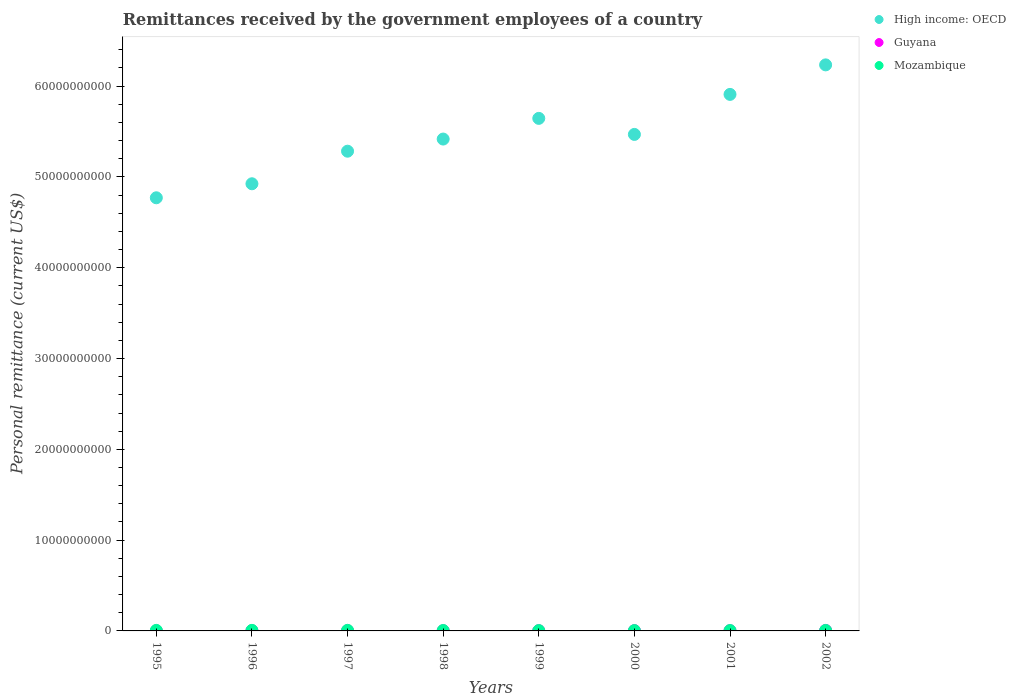How many different coloured dotlines are there?
Give a very brief answer. 3. What is the remittances received by the government employees in Guyana in 1995?
Offer a very short reply. 1.70e+06. Across all years, what is the maximum remittances received by the government employees in Mozambique?
Give a very brief answer. 6.36e+07. Across all years, what is the minimum remittances received by the government employees in Guyana?
Make the answer very short. 1.70e+06. In which year was the remittances received by the government employees in High income: OECD maximum?
Give a very brief answer. 2002. In which year was the remittances received by the government employees in Mozambique minimum?
Offer a very short reply. 2000. What is the total remittances received by the government employees in Guyana in the graph?
Make the answer very short. 1.66e+08. What is the difference between the remittances received by the government employees in High income: OECD in 1996 and that in 1997?
Give a very brief answer. -3.59e+09. What is the difference between the remittances received by the government employees in Guyana in 1998 and the remittances received by the government employees in High income: OECD in 2000?
Keep it short and to the point. -5.47e+1. What is the average remittances received by the government employees in High income: OECD per year?
Offer a terse response. 5.46e+1. In the year 1998, what is the difference between the remittances received by the government employees in Mozambique and remittances received by the government employees in High income: OECD?
Offer a terse response. -5.41e+1. In how many years, is the remittances received by the government employees in High income: OECD greater than 40000000000 US$?
Give a very brief answer. 8. What is the ratio of the remittances received by the government employees in Guyana in 1999 to that in 2002?
Your answer should be compact. 0.4. Is the difference between the remittances received by the government employees in Mozambique in 1998 and 2001 greater than the difference between the remittances received by the government employees in High income: OECD in 1998 and 2001?
Provide a succinct answer. Yes. What is the difference between the highest and the second highest remittances received by the government employees in Mozambique?
Provide a short and direct response. 2.60e+06. What is the difference between the highest and the lowest remittances received by the government employees in Mozambique?
Your response must be concise. 2.68e+07. Is the sum of the remittances received by the government employees in High income: OECD in 1995 and 1997 greater than the maximum remittances received by the government employees in Mozambique across all years?
Make the answer very short. Yes. Does the remittances received by the government employees in High income: OECD monotonically increase over the years?
Keep it short and to the point. No. Is the remittances received by the government employees in High income: OECD strictly less than the remittances received by the government employees in Guyana over the years?
Make the answer very short. No. How many dotlines are there?
Make the answer very short. 3. How many years are there in the graph?
Make the answer very short. 8. What is the difference between two consecutive major ticks on the Y-axis?
Offer a terse response. 1.00e+1. Does the graph contain any zero values?
Your answer should be compact. No. How are the legend labels stacked?
Your response must be concise. Vertical. What is the title of the graph?
Keep it short and to the point. Remittances received by the government employees of a country. What is the label or title of the Y-axis?
Give a very brief answer. Personal remittance (current US$). What is the Personal remittance (current US$) in High income: OECD in 1995?
Keep it short and to the point. 4.77e+1. What is the Personal remittance (current US$) of Guyana in 1995?
Keep it short and to the point. 1.70e+06. What is the Personal remittance (current US$) in Mozambique in 1995?
Ensure brevity in your answer.  5.91e+07. What is the Personal remittance (current US$) in High income: OECD in 1996?
Offer a very short reply. 4.92e+1. What is the Personal remittance (current US$) in Guyana in 1996?
Offer a terse response. 1.46e+07. What is the Personal remittance (current US$) of Mozambique in 1996?
Ensure brevity in your answer.  6.10e+07. What is the Personal remittance (current US$) in High income: OECD in 1997?
Offer a terse response. 5.28e+1. What is the Personal remittance (current US$) in Guyana in 1997?
Give a very brief answer. 1.50e+07. What is the Personal remittance (current US$) in Mozambique in 1997?
Ensure brevity in your answer.  6.36e+07. What is the Personal remittance (current US$) of High income: OECD in 1998?
Provide a short and direct response. 5.42e+1. What is the Personal remittance (current US$) in Guyana in 1998?
Offer a very short reply. 1.40e+07. What is the Personal remittance (current US$) in Mozambique in 1998?
Offer a very short reply. 4.63e+07. What is the Personal remittance (current US$) of High income: OECD in 1999?
Your answer should be compact. 5.64e+1. What is the Personal remittance (current US$) of Guyana in 1999?
Provide a short and direct response. 2.05e+07. What is the Personal remittance (current US$) of Mozambique in 1999?
Ensure brevity in your answer.  3.80e+07. What is the Personal remittance (current US$) of High income: OECD in 2000?
Provide a succinct answer. 5.47e+1. What is the Personal remittance (current US$) of Guyana in 2000?
Keep it short and to the point. 2.73e+07. What is the Personal remittance (current US$) of Mozambique in 2000?
Your answer should be compact. 3.68e+07. What is the Personal remittance (current US$) in High income: OECD in 2001?
Give a very brief answer. 5.91e+1. What is the Personal remittance (current US$) in Guyana in 2001?
Provide a short and direct response. 2.23e+07. What is the Personal remittance (current US$) in Mozambique in 2001?
Offer a terse response. 4.18e+07. What is the Personal remittance (current US$) of High income: OECD in 2002?
Offer a terse response. 6.23e+1. What is the Personal remittance (current US$) in Guyana in 2002?
Offer a terse response. 5.10e+07. What is the Personal remittance (current US$) of Mozambique in 2002?
Offer a very short reply. 5.26e+07. Across all years, what is the maximum Personal remittance (current US$) in High income: OECD?
Your answer should be compact. 6.23e+1. Across all years, what is the maximum Personal remittance (current US$) in Guyana?
Provide a short and direct response. 5.10e+07. Across all years, what is the maximum Personal remittance (current US$) in Mozambique?
Keep it short and to the point. 6.36e+07. Across all years, what is the minimum Personal remittance (current US$) in High income: OECD?
Ensure brevity in your answer.  4.77e+1. Across all years, what is the minimum Personal remittance (current US$) in Guyana?
Your response must be concise. 1.70e+06. Across all years, what is the minimum Personal remittance (current US$) in Mozambique?
Provide a short and direct response. 3.68e+07. What is the total Personal remittance (current US$) of High income: OECD in the graph?
Offer a very short reply. 4.37e+11. What is the total Personal remittance (current US$) of Guyana in the graph?
Make the answer very short. 1.66e+08. What is the total Personal remittance (current US$) of Mozambique in the graph?
Provide a succinct answer. 3.99e+08. What is the difference between the Personal remittance (current US$) of High income: OECD in 1995 and that in 1996?
Offer a terse response. -1.54e+09. What is the difference between the Personal remittance (current US$) of Guyana in 1995 and that in 1996?
Your answer should be very brief. -1.29e+07. What is the difference between the Personal remittance (current US$) in Mozambique in 1995 and that in 1996?
Your answer should be very brief. -1.90e+06. What is the difference between the Personal remittance (current US$) of High income: OECD in 1995 and that in 1997?
Provide a succinct answer. -5.13e+09. What is the difference between the Personal remittance (current US$) in Guyana in 1995 and that in 1997?
Provide a succinct answer. -1.33e+07. What is the difference between the Personal remittance (current US$) of Mozambique in 1995 and that in 1997?
Provide a short and direct response. -4.50e+06. What is the difference between the Personal remittance (current US$) in High income: OECD in 1995 and that in 1998?
Your answer should be very brief. -6.47e+09. What is the difference between the Personal remittance (current US$) of Guyana in 1995 and that in 1998?
Your response must be concise. -1.23e+07. What is the difference between the Personal remittance (current US$) of Mozambique in 1995 and that in 1998?
Keep it short and to the point. 1.28e+07. What is the difference between the Personal remittance (current US$) of High income: OECD in 1995 and that in 1999?
Your response must be concise. -8.75e+09. What is the difference between the Personal remittance (current US$) in Guyana in 1995 and that in 1999?
Provide a succinct answer. -1.88e+07. What is the difference between the Personal remittance (current US$) of Mozambique in 1995 and that in 1999?
Your response must be concise. 2.11e+07. What is the difference between the Personal remittance (current US$) in High income: OECD in 1995 and that in 2000?
Give a very brief answer. -6.98e+09. What is the difference between the Personal remittance (current US$) in Guyana in 1995 and that in 2000?
Offer a very short reply. -2.56e+07. What is the difference between the Personal remittance (current US$) in Mozambique in 1995 and that in 2000?
Your response must be concise. 2.23e+07. What is the difference between the Personal remittance (current US$) of High income: OECD in 1995 and that in 2001?
Offer a very short reply. -1.14e+1. What is the difference between the Personal remittance (current US$) in Guyana in 1995 and that in 2001?
Offer a very short reply. -2.06e+07. What is the difference between the Personal remittance (current US$) in Mozambique in 1995 and that in 2001?
Keep it short and to the point. 1.73e+07. What is the difference between the Personal remittance (current US$) in High income: OECD in 1995 and that in 2002?
Offer a very short reply. -1.46e+1. What is the difference between the Personal remittance (current US$) in Guyana in 1995 and that in 2002?
Your answer should be compact. -4.93e+07. What is the difference between the Personal remittance (current US$) in Mozambique in 1995 and that in 2002?
Your response must be concise. 6.55e+06. What is the difference between the Personal remittance (current US$) of High income: OECD in 1996 and that in 1997?
Give a very brief answer. -3.59e+09. What is the difference between the Personal remittance (current US$) in Guyana in 1996 and that in 1997?
Ensure brevity in your answer.  -4.00e+05. What is the difference between the Personal remittance (current US$) of Mozambique in 1996 and that in 1997?
Provide a short and direct response. -2.60e+06. What is the difference between the Personal remittance (current US$) in High income: OECD in 1996 and that in 1998?
Your answer should be compact. -4.92e+09. What is the difference between the Personal remittance (current US$) in Guyana in 1996 and that in 1998?
Ensure brevity in your answer.  6.00e+05. What is the difference between the Personal remittance (current US$) of Mozambique in 1996 and that in 1998?
Offer a terse response. 1.47e+07. What is the difference between the Personal remittance (current US$) in High income: OECD in 1996 and that in 1999?
Offer a very short reply. -7.20e+09. What is the difference between the Personal remittance (current US$) of Guyana in 1996 and that in 1999?
Your answer should be compact. -5.90e+06. What is the difference between the Personal remittance (current US$) in Mozambique in 1996 and that in 1999?
Ensure brevity in your answer.  2.30e+07. What is the difference between the Personal remittance (current US$) in High income: OECD in 1996 and that in 2000?
Make the answer very short. -5.44e+09. What is the difference between the Personal remittance (current US$) in Guyana in 1996 and that in 2000?
Offer a very short reply. -1.27e+07. What is the difference between the Personal remittance (current US$) in Mozambique in 1996 and that in 2000?
Your response must be concise. 2.42e+07. What is the difference between the Personal remittance (current US$) of High income: OECD in 1996 and that in 2001?
Offer a terse response. -9.84e+09. What is the difference between the Personal remittance (current US$) of Guyana in 1996 and that in 2001?
Ensure brevity in your answer.  -7.70e+06. What is the difference between the Personal remittance (current US$) in Mozambique in 1996 and that in 2001?
Offer a terse response. 1.92e+07. What is the difference between the Personal remittance (current US$) of High income: OECD in 1996 and that in 2002?
Make the answer very short. -1.31e+1. What is the difference between the Personal remittance (current US$) in Guyana in 1996 and that in 2002?
Make the answer very short. -3.64e+07. What is the difference between the Personal remittance (current US$) of Mozambique in 1996 and that in 2002?
Keep it short and to the point. 8.45e+06. What is the difference between the Personal remittance (current US$) in High income: OECD in 1997 and that in 1998?
Your response must be concise. -1.34e+09. What is the difference between the Personal remittance (current US$) in Guyana in 1997 and that in 1998?
Keep it short and to the point. 1.00e+06. What is the difference between the Personal remittance (current US$) in Mozambique in 1997 and that in 1998?
Your answer should be very brief. 1.73e+07. What is the difference between the Personal remittance (current US$) of High income: OECD in 1997 and that in 1999?
Offer a terse response. -3.61e+09. What is the difference between the Personal remittance (current US$) in Guyana in 1997 and that in 1999?
Provide a short and direct response. -5.50e+06. What is the difference between the Personal remittance (current US$) in Mozambique in 1997 and that in 1999?
Your answer should be very brief. 2.56e+07. What is the difference between the Personal remittance (current US$) of High income: OECD in 1997 and that in 2000?
Provide a succinct answer. -1.85e+09. What is the difference between the Personal remittance (current US$) of Guyana in 1997 and that in 2000?
Your response must be concise. -1.23e+07. What is the difference between the Personal remittance (current US$) of Mozambique in 1997 and that in 2000?
Your response must be concise. 2.68e+07. What is the difference between the Personal remittance (current US$) of High income: OECD in 1997 and that in 2001?
Offer a very short reply. -6.26e+09. What is the difference between the Personal remittance (current US$) in Guyana in 1997 and that in 2001?
Keep it short and to the point. -7.30e+06. What is the difference between the Personal remittance (current US$) of Mozambique in 1997 and that in 2001?
Your response must be concise. 2.18e+07. What is the difference between the Personal remittance (current US$) in High income: OECD in 1997 and that in 2002?
Your response must be concise. -9.51e+09. What is the difference between the Personal remittance (current US$) in Guyana in 1997 and that in 2002?
Keep it short and to the point. -3.60e+07. What is the difference between the Personal remittance (current US$) in Mozambique in 1997 and that in 2002?
Your response must be concise. 1.10e+07. What is the difference between the Personal remittance (current US$) of High income: OECD in 1998 and that in 1999?
Provide a short and direct response. -2.28e+09. What is the difference between the Personal remittance (current US$) in Guyana in 1998 and that in 1999?
Your answer should be compact. -6.50e+06. What is the difference between the Personal remittance (current US$) of Mozambique in 1998 and that in 1999?
Your answer should be compact. 8.30e+06. What is the difference between the Personal remittance (current US$) of High income: OECD in 1998 and that in 2000?
Ensure brevity in your answer.  -5.11e+08. What is the difference between the Personal remittance (current US$) of Guyana in 1998 and that in 2000?
Give a very brief answer. -1.33e+07. What is the difference between the Personal remittance (current US$) of Mozambique in 1998 and that in 2000?
Your answer should be compact. 9.50e+06. What is the difference between the Personal remittance (current US$) in High income: OECD in 1998 and that in 2001?
Your response must be concise. -4.92e+09. What is the difference between the Personal remittance (current US$) of Guyana in 1998 and that in 2001?
Your answer should be compact. -8.30e+06. What is the difference between the Personal remittance (current US$) of Mozambique in 1998 and that in 2001?
Give a very brief answer. 4.48e+06. What is the difference between the Personal remittance (current US$) of High income: OECD in 1998 and that in 2002?
Give a very brief answer. -8.17e+09. What is the difference between the Personal remittance (current US$) in Guyana in 1998 and that in 2002?
Offer a very short reply. -3.70e+07. What is the difference between the Personal remittance (current US$) in Mozambique in 1998 and that in 2002?
Make the answer very short. -6.25e+06. What is the difference between the Personal remittance (current US$) in High income: OECD in 1999 and that in 2000?
Make the answer very short. 1.77e+09. What is the difference between the Personal remittance (current US$) of Guyana in 1999 and that in 2000?
Provide a short and direct response. -6.80e+06. What is the difference between the Personal remittance (current US$) in Mozambique in 1999 and that in 2000?
Your response must be concise. 1.20e+06. What is the difference between the Personal remittance (current US$) of High income: OECD in 1999 and that in 2001?
Your response must be concise. -2.64e+09. What is the difference between the Personal remittance (current US$) in Guyana in 1999 and that in 2001?
Make the answer very short. -1.80e+06. What is the difference between the Personal remittance (current US$) of Mozambique in 1999 and that in 2001?
Keep it short and to the point. -3.82e+06. What is the difference between the Personal remittance (current US$) of High income: OECD in 1999 and that in 2002?
Give a very brief answer. -5.89e+09. What is the difference between the Personal remittance (current US$) in Guyana in 1999 and that in 2002?
Your answer should be very brief. -3.05e+07. What is the difference between the Personal remittance (current US$) of Mozambique in 1999 and that in 2002?
Give a very brief answer. -1.46e+07. What is the difference between the Personal remittance (current US$) in High income: OECD in 2000 and that in 2001?
Give a very brief answer. -4.41e+09. What is the difference between the Personal remittance (current US$) in Mozambique in 2000 and that in 2001?
Ensure brevity in your answer.  -5.02e+06. What is the difference between the Personal remittance (current US$) in High income: OECD in 2000 and that in 2002?
Your answer should be very brief. -7.66e+09. What is the difference between the Personal remittance (current US$) of Guyana in 2000 and that in 2002?
Make the answer very short. -2.37e+07. What is the difference between the Personal remittance (current US$) of Mozambique in 2000 and that in 2002?
Your answer should be compact. -1.58e+07. What is the difference between the Personal remittance (current US$) in High income: OECD in 2001 and that in 2002?
Offer a terse response. -3.25e+09. What is the difference between the Personal remittance (current US$) in Guyana in 2001 and that in 2002?
Your response must be concise. -2.87e+07. What is the difference between the Personal remittance (current US$) in Mozambique in 2001 and that in 2002?
Make the answer very short. -1.07e+07. What is the difference between the Personal remittance (current US$) in High income: OECD in 1995 and the Personal remittance (current US$) in Guyana in 1996?
Your response must be concise. 4.77e+1. What is the difference between the Personal remittance (current US$) of High income: OECD in 1995 and the Personal remittance (current US$) of Mozambique in 1996?
Your response must be concise. 4.76e+1. What is the difference between the Personal remittance (current US$) of Guyana in 1995 and the Personal remittance (current US$) of Mozambique in 1996?
Your answer should be compact. -5.93e+07. What is the difference between the Personal remittance (current US$) in High income: OECD in 1995 and the Personal remittance (current US$) in Guyana in 1997?
Your answer should be very brief. 4.77e+1. What is the difference between the Personal remittance (current US$) of High income: OECD in 1995 and the Personal remittance (current US$) of Mozambique in 1997?
Your response must be concise. 4.76e+1. What is the difference between the Personal remittance (current US$) in Guyana in 1995 and the Personal remittance (current US$) in Mozambique in 1997?
Provide a short and direct response. -6.19e+07. What is the difference between the Personal remittance (current US$) in High income: OECD in 1995 and the Personal remittance (current US$) in Guyana in 1998?
Your response must be concise. 4.77e+1. What is the difference between the Personal remittance (current US$) in High income: OECD in 1995 and the Personal remittance (current US$) in Mozambique in 1998?
Your answer should be compact. 4.77e+1. What is the difference between the Personal remittance (current US$) in Guyana in 1995 and the Personal remittance (current US$) in Mozambique in 1998?
Ensure brevity in your answer.  -4.46e+07. What is the difference between the Personal remittance (current US$) of High income: OECD in 1995 and the Personal remittance (current US$) of Guyana in 1999?
Offer a terse response. 4.77e+1. What is the difference between the Personal remittance (current US$) of High income: OECD in 1995 and the Personal remittance (current US$) of Mozambique in 1999?
Ensure brevity in your answer.  4.77e+1. What is the difference between the Personal remittance (current US$) of Guyana in 1995 and the Personal remittance (current US$) of Mozambique in 1999?
Your answer should be compact. -3.63e+07. What is the difference between the Personal remittance (current US$) in High income: OECD in 1995 and the Personal remittance (current US$) in Guyana in 2000?
Your answer should be compact. 4.77e+1. What is the difference between the Personal remittance (current US$) of High income: OECD in 1995 and the Personal remittance (current US$) of Mozambique in 2000?
Keep it short and to the point. 4.77e+1. What is the difference between the Personal remittance (current US$) in Guyana in 1995 and the Personal remittance (current US$) in Mozambique in 2000?
Your response must be concise. -3.51e+07. What is the difference between the Personal remittance (current US$) in High income: OECD in 1995 and the Personal remittance (current US$) in Guyana in 2001?
Your answer should be very brief. 4.77e+1. What is the difference between the Personal remittance (current US$) of High income: OECD in 1995 and the Personal remittance (current US$) of Mozambique in 2001?
Keep it short and to the point. 4.77e+1. What is the difference between the Personal remittance (current US$) of Guyana in 1995 and the Personal remittance (current US$) of Mozambique in 2001?
Provide a succinct answer. -4.01e+07. What is the difference between the Personal remittance (current US$) in High income: OECD in 1995 and the Personal remittance (current US$) in Guyana in 2002?
Offer a terse response. 4.77e+1. What is the difference between the Personal remittance (current US$) of High income: OECD in 1995 and the Personal remittance (current US$) of Mozambique in 2002?
Keep it short and to the point. 4.77e+1. What is the difference between the Personal remittance (current US$) of Guyana in 1995 and the Personal remittance (current US$) of Mozambique in 2002?
Your answer should be very brief. -5.09e+07. What is the difference between the Personal remittance (current US$) in High income: OECD in 1996 and the Personal remittance (current US$) in Guyana in 1997?
Ensure brevity in your answer.  4.92e+1. What is the difference between the Personal remittance (current US$) of High income: OECD in 1996 and the Personal remittance (current US$) of Mozambique in 1997?
Make the answer very short. 4.92e+1. What is the difference between the Personal remittance (current US$) of Guyana in 1996 and the Personal remittance (current US$) of Mozambique in 1997?
Offer a terse response. -4.90e+07. What is the difference between the Personal remittance (current US$) in High income: OECD in 1996 and the Personal remittance (current US$) in Guyana in 1998?
Give a very brief answer. 4.92e+1. What is the difference between the Personal remittance (current US$) of High income: OECD in 1996 and the Personal remittance (current US$) of Mozambique in 1998?
Provide a short and direct response. 4.92e+1. What is the difference between the Personal remittance (current US$) of Guyana in 1996 and the Personal remittance (current US$) of Mozambique in 1998?
Offer a terse response. -3.17e+07. What is the difference between the Personal remittance (current US$) of High income: OECD in 1996 and the Personal remittance (current US$) of Guyana in 1999?
Provide a short and direct response. 4.92e+1. What is the difference between the Personal remittance (current US$) of High income: OECD in 1996 and the Personal remittance (current US$) of Mozambique in 1999?
Give a very brief answer. 4.92e+1. What is the difference between the Personal remittance (current US$) in Guyana in 1996 and the Personal remittance (current US$) in Mozambique in 1999?
Offer a very short reply. -2.34e+07. What is the difference between the Personal remittance (current US$) in High income: OECD in 1996 and the Personal remittance (current US$) in Guyana in 2000?
Provide a succinct answer. 4.92e+1. What is the difference between the Personal remittance (current US$) in High income: OECD in 1996 and the Personal remittance (current US$) in Mozambique in 2000?
Provide a succinct answer. 4.92e+1. What is the difference between the Personal remittance (current US$) in Guyana in 1996 and the Personal remittance (current US$) in Mozambique in 2000?
Offer a terse response. -2.22e+07. What is the difference between the Personal remittance (current US$) in High income: OECD in 1996 and the Personal remittance (current US$) in Guyana in 2001?
Your response must be concise. 4.92e+1. What is the difference between the Personal remittance (current US$) of High income: OECD in 1996 and the Personal remittance (current US$) of Mozambique in 2001?
Your answer should be very brief. 4.92e+1. What is the difference between the Personal remittance (current US$) of Guyana in 1996 and the Personal remittance (current US$) of Mozambique in 2001?
Make the answer very short. -2.72e+07. What is the difference between the Personal remittance (current US$) of High income: OECD in 1996 and the Personal remittance (current US$) of Guyana in 2002?
Offer a very short reply. 4.92e+1. What is the difference between the Personal remittance (current US$) of High income: OECD in 1996 and the Personal remittance (current US$) of Mozambique in 2002?
Make the answer very short. 4.92e+1. What is the difference between the Personal remittance (current US$) in Guyana in 1996 and the Personal remittance (current US$) in Mozambique in 2002?
Your response must be concise. -3.80e+07. What is the difference between the Personal remittance (current US$) of High income: OECD in 1997 and the Personal remittance (current US$) of Guyana in 1998?
Make the answer very short. 5.28e+1. What is the difference between the Personal remittance (current US$) of High income: OECD in 1997 and the Personal remittance (current US$) of Mozambique in 1998?
Your answer should be compact. 5.28e+1. What is the difference between the Personal remittance (current US$) in Guyana in 1997 and the Personal remittance (current US$) in Mozambique in 1998?
Offer a very short reply. -3.13e+07. What is the difference between the Personal remittance (current US$) of High income: OECD in 1997 and the Personal remittance (current US$) of Guyana in 1999?
Keep it short and to the point. 5.28e+1. What is the difference between the Personal remittance (current US$) of High income: OECD in 1997 and the Personal remittance (current US$) of Mozambique in 1999?
Your response must be concise. 5.28e+1. What is the difference between the Personal remittance (current US$) in Guyana in 1997 and the Personal remittance (current US$) in Mozambique in 1999?
Your answer should be very brief. -2.30e+07. What is the difference between the Personal remittance (current US$) in High income: OECD in 1997 and the Personal remittance (current US$) in Guyana in 2000?
Keep it short and to the point. 5.28e+1. What is the difference between the Personal remittance (current US$) of High income: OECD in 1997 and the Personal remittance (current US$) of Mozambique in 2000?
Offer a terse response. 5.28e+1. What is the difference between the Personal remittance (current US$) in Guyana in 1997 and the Personal remittance (current US$) in Mozambique in 2000?
Keep it short and to the point. -2.18e+07. What is the difference between the Personal remittance (current US$) in High income: OECD in 1997 and the Personal remittance (current US$) in Guyana in 2001?
Offer a very short reply. 5.28e+1. What is the difference between the Personal remittance (current US$) in High income: OECD in 1997 and the Personal remittance (current US$) in Mozambique in 2001?
Provide a short and direct response. 5.28e+1. What is the difference between the Personal remittance (current US$) of Guyana in 1997 and the Personal remittance (current US$) of Mozambique in 2001?
Provide a succinct answer. -2.68e+07. What is the difference between the Personal remittance (current US$) in High income: OECD in 1997 and the Personal remittance (current US$) in Guyana in 2002?
Ensure brevity in your answer.  5.28e+1. What is the difference between the Personal remittance (current US$) of High income: OECD in 1997 and the Personal remittance (current US$) of Mozambique in 2002?
Your answer should be compact. 5.28e+1. What is the difference between the Personal remittance (current US$) in Guyana in 1997 and the Personal remittance (current US$) in Mozambique in 2002?
Offer a terse response. -3.76e+07. What is the difference between the Personal remittance (current US$) of High income: OECD in 1998 and the Personal remittance (current US$) of Guyana in 1999?
Ensure brevity in your answer.  5.42e+1. What is the difference between the Personal remittance (current US$) in High income: OECD in 1998 and the Personal remittance (current US$) in Mozambique in 1999?
Make the answer very short. 5.41e+1. What is the difference between the Personal remittance (current US$) in Guyana in 1998 and the Personal remittance (current US$) in Mozambique in 1999?
Provide a succinct answer. -2.40e+07. What is the difference between the Personal remittance (current US$) of High income: OECD in 1998 and the Personal remittance (current US$) of Guyana in 2000?
Offer a very short reply. 5.41e+1. What is the difference between the Personal remittance (current US$) of High income: OECD in 1998 and the Personal remittance (current US$) of Mozambique in 2000?
Your response must be concise. 5.41e+1. What is the difference between the Personal remittance (current US$) in Guyana in 1998 and the Personal remittance (current US$) in Mozambique in 2000?
Make the answer very short. -2.28e+07. What is the difference between the Personal remittance (current US$) in High income: OECD in 1998 and the Personal remittance (current US$) in Guyana in 2001?
Your answer should be compact. 5.41e+1. What is the difference between the Personal remittance (current US$) of High income: OECD in 1998 and the Personal remittance (current US$) of Mozambique in 2001?
Offer a terse response. 5.41e+1. What is the difference between the Personal remittance (current US$) in Guyana in 1998 and the Personal remittance (current US$) in Mozambique in 2001?
Make the answer very short. -2.78e+07. What is the difference between the Personal remittance (current US$) of High income: OECD in 1998 and the Personal remittance (current US$) of Guyana in 2002?
Your answer should be very brief. 5.41e+1. What is the difference between the Personal remittance (current US$) in High income: OECD in 1998 and the Personal remittance (current US$) in Mozambique in 2002?
Offer a very short reply. 5.41e+1. What is the difference between the Personal remittance (current US$) in Guyana in 1998 and the Personal remittance (current US$) in Mozambique in 2002?
Make the answer very short. -3.86e+07. What is the difference between the Personal remittance (current US$) of High income: OECD in 1999 and the Personal remittance (current US$) of Guyana in 2000?
Offer a very short reply. 5.64e+1. What is the difference between the Personal remittance (current US$) of High income: OECD in 1999 and the Personal remittance (current US$) of Mozambique in 2000?
Make the answer very short. 5.64e+1. What is the difference between the Personal remittance (current US$) in Guyana in 1999 and the Personal remittance (current US$) in Mozambique in 2000?
Offer a very short reply. -1.63e+07. What is the difference between the Personal remittance (current US$) in High income: OECD in 1999 and the Personal remittance (current US$) in Guyana in 2001?
Provide a short and direct response. 5.64e+1. What is the difference between the Personal remittance (current US$) of High income: OECD in 1999 and the Personal remittance (current US$) of Mozambique in 2001?
Offer a terse response. 5.64e+1. What is the difference between the Personal remittance (current US$) of Guyana in 1999 and the Personal remittance (current US$) of Mozambique in 2001?
Your response must be concise. -2.13e+07. What is the difference between the Personal remittance (current US$) of High income: OECD in 1999 and the Personal remittance (current US$) of Guyana in 2002?
Make the answer very short. 5.64e+1. What is the difference between the Personal remittance (current US$) of High income: OECD in 1999 and the Personal remittance (current US$) of Mozambique in 2002?
Ensure brevity in your answer.  5.64e+1. What is the difference between the Personal remittance (current US$) of Guyana in 1999 and the Personal remittance (current US$) of Mozambique in 2002?
Ensure brevity in your answer.  -3.21e+07. What is the difference between the Personal remittance (current US$) in High income: OECD in 2000 and the Personal remittance (current US$) in Guyana in 2001?
Your answer should be very brief. 5.47e+1. What is the difference between the Personal remittance (current US$) in High income: OECD in 2000 and the Personal remittance (current US$) in Mozambique in 2001?
Make the answer very short. 5.46e+1. What is the difference between the Personal remittance (current US$) in Guyana in 2000 and the Personal remittance (current US$) in Mozambique in 2001?
Your response must be concise. -1.45e+07. What is the difference between the Personal remittance (current US$) in High income: OECD in 2000 and the Personal remittance (current US$) in Guyana in 2002?
Offer a very short reply. 5.46e+1. What is the difference between the Personal remittance (current US$) of High income: OECD in 2000 and the Personal remittance (current US$) of Mozambique in 2002?
Make the answer very short. 5.46e+1. What is the difference between the Personal remittance (current US$) in Guyana in 2000 and the Personal remittance (current US$) in Mozambique in 2002?
Offer a very short reply. -2.53e+07. What is the difference between the Personal remittance (current US$) in High income: OECD in 2001 and the Personal remittance (current US$) in Guyana in 2002?
Your answer should be very brief. 5.90e+1. What is the difference between the Personal remittance (current US$) of High income: OECD in 2001 and the Personal remittance (current US$) of Mozambique in 2002?
Give a very brief answer. 5.90e+1. What is the difference between the Personal remittance (current US$) in Guyana in 2001 and the Personal remittance (current US$) in Mozambique in 2002?
Provide a short and direct response. -3.03e+07. What is the average Personal remittance (current US$) of High income: OECD per year?
Provide a short and direct response. 5.46e+1. What is the average Personal remittance (current US$) of Guyana per year?
Your answer should be very brief. 2.08e+07. What is the average Personal remittance (current US$) of Mozambique per year?
Provide a succinct answer. 4.99e+07. In the year 1995, what is the difference between the Personal remittance (current US$) of High income: OECD and Personal remittance (current US$) of Guyana?
Offer a terse response. 4.77e+1. In the year 1995, what is the difference between the Personal remittance (current US$) of High income: OECD and Personal remittance (current US$) of Mozambique?
Ensure brevity in your answer.  4.76e+1. In the year 1995, what is the difference between the Personal remittance (current US$) of Guyana and Personal remittance (current US$) of Mozambique?
Your response must be concise. -5.74e+07. In the year 1996, what is the difference between the Personal remittance (current US$) in High income: OECD and Personal remittance (current US$) in Guyana?
Offer a very short reply. 4.92e+1. In the year 1996, what is the difference between the Personal remittance (current US$) in High income: OECD and Personal remittance (current US$) in Mozambique?
Your response must be concise. 4.92e+1. In the year 1996, what is the difference between the Personal remittance (current US$) in Guyana and Personal remittance (current US$) in Mozambique?
Give a very brief answer. -4.64e+07. In the year 1997, what is the difference between the Personal remittance (current US$) in High income: OECD and Personal remittance (current US$) in Guyana?
Give a very brief answer. 5.28e+1. In the year 1997, what is the difference between the Personal remittance (current US$) in High income: OECD and Personal remittance (current US$) in Mozambique?
Keep it short and to the point. 5.28e+1. In the year 1997, what is the difference between the Personal remittance (current US$) of Guyana and Personal remittance (current US$) of Mozambique?
Keep it short and to the point. -4.86e+07. In the year 1998, what is the difference between the Personal remittance (current US$) in High income: OECD and Personal remittance (current US$) in Guyana?
Give a very brief answer. 5.42e+1. In the year 1998, what is the difference between the Personal remittance (current US$) in High income: OECD and Personal remittance (current US$) in Mozambique?
Your answer should be very brief. 5.41e+1. In the year 1998, what is the difference between the Personal remittance (current US$) of Guyana and Personal remittance (current US$) of Mozambique?
Your answer should be compact. -3.23e+07. In the year 1999, what is the difference between the Personal remittance (current US$) of High income: OECD and Personal remittance (current US$) of Guyana?
Your answer should be very brief. 5.64e+1. In the year 1999, what is the difference between the Personal remittance (current US$) of High income: OECD and Personal remittance (current US$) of Mozambique?
Provide a short and direct response. 5.64e+1. In the year 1999, what is the difference between the Personal remittance (current US$) of Guyana and Personal remittance (current US$) of Mozambique?
Your answer should be compact. -1.75e+07. In the year 2000, what is the difference between the Personal remittance (current US$) of High income: OECD and Personal remittance (current US$) of Guyana?
Your answer should be very brief. 5.47e+1. In the year 2000, what is the difference between the Personal remittance (current US$) of High income: OECD and Personal remittance (current US$) of Mozambique?
Your answer should be very brief. 5.46e+1. In the year 2000, what is the difference between the Personal remittance (current US$) in Guyana and Personal remittance (current US$) in Mozambique?
Offer a very short reply. -9.50e+06. In the year 2001, what is the difference between the Personal remittance (current US$) of High income: OECD and Personal remittance (current US$) of Guyana?
Provide a succinct answer. 5.91e+1. In the year 2001, what is the difference between the Personal remittance (current US$) of High income: OECD and Personal remittance (current US$) of Mozambique?
Provide a succinct answer. 5.90e+1. In the year 2001, what is the difference between the Personal remittance (current US$) of Guyana and Personal remittance (current US$) of Mozambique?
Your answer should be very brief. -1.95e+07. In the year 2002, what is the difference between the Personal remittance (current US$) of High income: OECD and Personal remittance (current US$) of Guyana?
Your answer should be compact. 6.23e+1. In the year 2002, what is the difference between the Personal remittance (current US$) of High income: OECD and Personal remittance (current US$) of Mozambique?
Provide a succinct answer. 6.23e+1. In the year 2002, what is the difference between the Personal remittance (current US$) in Guyana and Personal remittance (current US$) in Mozambique?
Make the answer very short. -1.55e+06. What is the ratio of the Personal remittance (current US$) in High income: OECD in 1995 to that in 1996?
Your answer should be compact. 0.97. What is the ratio of the Personal remittance (current US$) of Guyana in 1995 to that in 1996?
Provide a short and direct response. 0.12. What is the ratio of the Personal remittance (current US$) in Mozambique in 1995 to that in 1996?
Ensure brevity in your answer.  0.97. What is the ratio of the Personal remittance (current US$) of High income: OECD in 1995 to that in 1997?
Your answer should be compact. 0.9. What is the ratio of the Personal remittance (current US$) in Guyana in 1995 to that in 1997?
Ensure brevity in your answer.  0.11. What is the ratio of the Personal remittance (current US$) in Mozambique in 1995 to that in 1997?
Make the answer very short. 0.93. What is the ratio of the Personal remittance (current US$) of High income: OECD in 1995 to that in 1998?
Keep it short and to the point. 0.88. What is the ratio of the Personal remittance (current US$) of Guyana in 1995 to that in 1998?
Your answer should be compact. 0.12. What is the ratio of the Personal remittance (current US$) in Mozambique in 1995 to that in 1998?
Provide a succinct answer. 1.28. What is the ratio of the Personal remittance (current US$) in High income: OECD in 1995 to that in 1999?
Make the answer very short. 0.85. What is the ratio of the Personal remittance (current US$) in Guyana in 1995 to that in 1999?
Ensure brevity in your answer.  0.08. What is the ratio of the Personal remittance (current US$) in Mozambique in 1995 to that in 1999?
Make the answer very short. 1.56. What is the ratio of the Personal remittance (current US$) in High income: OECD in 1995 to that in 2000?
Offer a very short reply. 0.87. What is the ratio of the Personal remittance (current US$) in Guyana in 1995 to that in 2000?
Keep it short and to the point. 0.06. What is the ratio of the Personal remittance (current US$) of Mozambique in 1995 to that in 2000?
Provide a succinct answer. 1.61. What is the ratio of the Personal remittance (current US$) of High income: OECD in 1995 to that in 2001?
Offer a terse response. 0.81. What is the ratio of the Personal remittance (current US$) in Guyana in 1995 to that in 2001?
Give a very brief answer. 0.08. What is the ratio of the Personal remittance (current US$) in Mozambique in 1995 to that in 2001?
Your answer should be compact. 1.41. What is the ratio of the Personal remittance (current US$) of High income: OECD in 1995 to that in 2002?
Make the answer very short. 0.77. What is the ratio of the Personal remittance (current US$) of Guyana in 1995 to that in 2002?
Provide a succinct answer. 0.03. What is the ratio of the Personal remittance (current US$) in Mozambique in 1995 to that in 2002?
Provide a succinct answer. 1.12. What is the ratio of the Personal remittance (current US$) of High income: OECD in 1996 to that in 1997?
Your answer should be compact. 0.93. What is the ratio of the Personal remittance (current US$) in Guyana in 1996 to that in 1997?
Provide a succinct answer. 0.97. What is the ratio of the Personal remittance (current US$) in Mozambique in 1996 to that in 1997?
Provide a succinct answer. 0.96. What is the ratio of the Personal remittance (current US$) of High income: OECD in 1996 to that in 1998?
Make the answer very short. 0.91. What is the ratio of the Personal remittance (current US$) in Guyana in 1996 to that in 1998?
Ensure brevity in your answer.  1.04. What is the ratio of the Personal remittance (current US$) of Mozambique in 1996 to that in 1998?
Give a very brief answer. 1.32. What is the ratio of the Personal remittance (current US$) of High income: OECD in 1996 to that in 1999?
Provide a succinct answer. 0.87. What is the ratio of the Personal remittance (current US$) of Guyana in 1996 to that in 1999?
Give a very brief answer. 0.71. What is the ratio of the Personal remittance (current US$) in Mozambique in 1996 to that in 1999?
Offer a very short reply. 1.61. What is the ratio of the Personal remittance (current US$) in High income: OECD in 1996 to that in 2000?
Give a very brief answer. 0.9. What is the ratio of the Personal remittance (current US$) in Guyana in 1996 to that in 2000?
Provide a succinct answer. 0.53. What is the ratio of the Personal remittance (current US$) in Mozambique in 1996 to that in 2000?
Your response must be concise. 1.66. What is the ratio of the Personal remittance (current US$) of High income: OECD in 1996 to that in 2001?
Ensure brevity in your answer.  0.83. What is the ratio of the Personal remittance (current US$) in Guyana in 1996 to that in 2001?
Give a very brief answer. 0.65. What is the ratio of the Personal remittance (current US$) of Mozambique in 1996 to that in 2001?
Offer a terse response. 1.46. What is the ratio of the Personal remittance (current US$) in High income: OECD in 1996 to that in 2002?
Give a very brief answer. 0.79. What is the ratio of the Personal remittance (current US$) in Guyana in 1996 to that in 2002?
Offer a terse response. 0.29. What is the ratio of the Personal remittance (current US$) in Mozambique in 1996 to that in 2002?
Ensure brevity in your answer.  1.16. What is the ratio of the Personal remittance (current US$) of High income: OECD in 1997 to that in 1998?
Offer a very short reply. 0.98. What is the ratio of the Personal remittance (current US$) of Guyana in 1997 to that in 1998?
Ensure brevity in your answer.  1.07. What is the ratio of the Personal remittance (current US$) in Mozambique in 1997 to that in 1998?
Offer a very short reply. 1.37. What is the ratio of the Personal remittance (current US$) in High income: OECD in 1997 to that in 1999?
Provide a succinct answer. 0.94. What is the ratio of the Personal remittance (current US$) in Guyana in 1997 to that in 1999?
Provide a succinct answer. 0.73. What is the ratio of the Personal remittance (current US$) of Mozambique in 1997 to that in 1999?
Provide a succinct answer. 1.67. What is the ratio of the Personal remittance (current US$) of High income: OECD in 1997 to that in 2000?
Make the answer very short. 0.97. What is the ratio of the Personal remittance (current US$) of Guyana in 1997 to that in 2000?
Your answer should be compact. 0.55. What is the ratio of the Personal remittance (current US$) in Mozambique in 1997 to that in 2000?
Offer a terse response. 1.73. What is the ratio of the Personal remittance (current US$) in High income: OECD in 1997 to that in 2001?
Your answer should be very brief. 0.89. What is the ratio of the Personal remittance (current US$) in Guyana in 1997 to that in 2001?
Your answer should be compact. 0.67. What is the ratio of the Personal remittance (current US$) of Mozambique in 1997 to that in 2001?
Your answer should be very brief. 1.52. What is the ratio of the Personal remittance (current US$) in High income: OECD in 1997 to that in 2002?
Provide a short and direct response. 0.85. What is the ratio of the Personal remittance (current US$) in Guyana in 1997 to that in 2002?
Your answer should be compact. 0.29. What is the ratio of the Personal remittance (current US$) of Mozambique in 1997 to that in 2002?
Your answer should be compact. 1.21. What is the ratio of the Personal remittance (current US$) in High income: OECD in 1998 to that in 1999?
Your answer should be very brief. 0.96. What is the ratio of the Personal remittance (current US$) of Guyana in 1998 to that in 1999?
Provide a succinct answer. 0.68. What is the ratio of the Personal remittance (current US$) in Mozambique in 1998 to that in 1999?
Give a very brief answer. 1.22. What is the ratio of the Personal remittance (current US$) of High income: OECD in 1998 to that in 2000?
Make the answer very short. 0.99. What is the ratio of the Personal remittance (current US$) of Guyana in 1998 to that in 2000?
Your response must be concise. 0.51. What is the ratio of the Personal remittance (current US$) of Mozambique in 1998 to that in 2000?
Your answer should be compact. 1.26. What is the ratio of the Personal remittance (current US$) of High income: OECD in 1998 to that in 2001?
Your response must be concise. 0.92. What is the ratio of the Personal remittance (current US$) of Guyana in 1998 to that in 2001?
Give a very brief answer. 0.63. What is the ratio of the Personal remittance (current US$) of Mozambique in 1998 to that in 2001?
Provide a succinct answer. 1.11. What is the ratio of the Personal remittance (current US$) of High income: OECD in 1998 to that in 2002?
Your answer should be very brief. 0.87. What is the ratio of the Personal remittance (current US$) of Guyana in 1998 to that in 2002?
Make the answer very short. 0.27. What is the ratio of the Personal remittance (current US$) in Mozambique in 1998 to that in 2002?
Offer a terse response. 0.88. What is the ratio of the Personal remittance (current US$) of High income: OECD in 1999 to that in 2000?
Provide a succinct answer. 1.03. What is the ratio of the Personal remittance (current US$) of Guyana in 1999 to that in 2000?
Offer a terse response. 0.75. What is the ratio of the Personal remittance (current US$) in Mozambique in 1999 to that in 2000?
Ensure brevity in your answer.  1.03. What is the ratio of the Personal remittance (current US$) of High income: OECD in 1999 to that in 2001?
Make the answer very short. 0.96. What is the ratio of the Personal remittance (current US$) of Guyana in 1999 to that in 2001?
Offer a terse response. 0.92. What is the ratio of the Personal remittance (current US$) in Mozambique in 1999 to that in 2001?
Offer a terse response. 0.91. What is the ratio of the Personal remittance (current US$) in High income: OECD in 1999 to that in 2002?
Offer a terse response. 0.91. What is the ratio of the Personal remittance (current US$) in Guyana in 1999 to that in 2002?
Your answer should be compact. 0.4. What is the ratio of the Personal remittance (current US$) of Mozambique in 1999 to that in 2002?
Keep it short and to the point. 0.72. What is the ratio of the Personal remittance (current US$) of High income: OECD in 2000 to that in 2001?
Your response must be concise. 0.93. What is the ratio of the Personal remittance (current US$) of Guyana in 2000 to that in 2001?
Your answer should be very brief. 1.22. What is the ratio of the Personal remittance (current US$) in Mozambique in 2000 to that in 2001?
Your response must be concise. 0.88. What is the ratio of the Personal remittance (current US$) in High income: OECD in 2000 to that in 2002?
Provide a short and direct response. 0.88. What is the ratio of the Personal remittance (current US$) of Guyana in 2000 to that in 2002?
Provide a short and direct response. 0.54. What is the ratio of the Personal remittance (current US$) in Mozambique in 2000 to that in 2002?
Provide a succinct answer. 0.7. What is the ratio of the Personal remittance (current US$) of High income: OECD in 2001 to that in 2002?
Provide a succinct answer. 0.95. What is the ratio of the Personal remittance (current US$) of Guyana in 2001 to that in 2002?
Ensure brevity in your answer.  0.44. What is the ratio of the Personal remittance (current US$) in Mozambique in 2001 to that in 2002?
Give a very brief answer. 0.8. What is the difference between the highest and the second highest Personal remittance (current US$) in High income: OECD?
Ensure brevity in your answer.  3.25e+09. What is the difference between the highest and the second highest Personal remittance (current US$) in Guyana?
Your response must be concise. 2.37e+07. What is the difference between the highest and the second highest Personal remittance (current US$) in Mozambique?
Make the answer very short. 2.60e+06. What is the difference between the highest and the lowest Personal remittance (current US$) of High income: OECD?
Give a very brief answer. 1.46e+1. What is the difference between the highest and the lowest Personal remittance (current US$) of Guyana?
Provide a succinct answer. 4.93e+07. What is the difference between the highest and the lowest Personal remittance (current US$) of Mozambique?
Your answer should be very brief. 2.68e+07. 